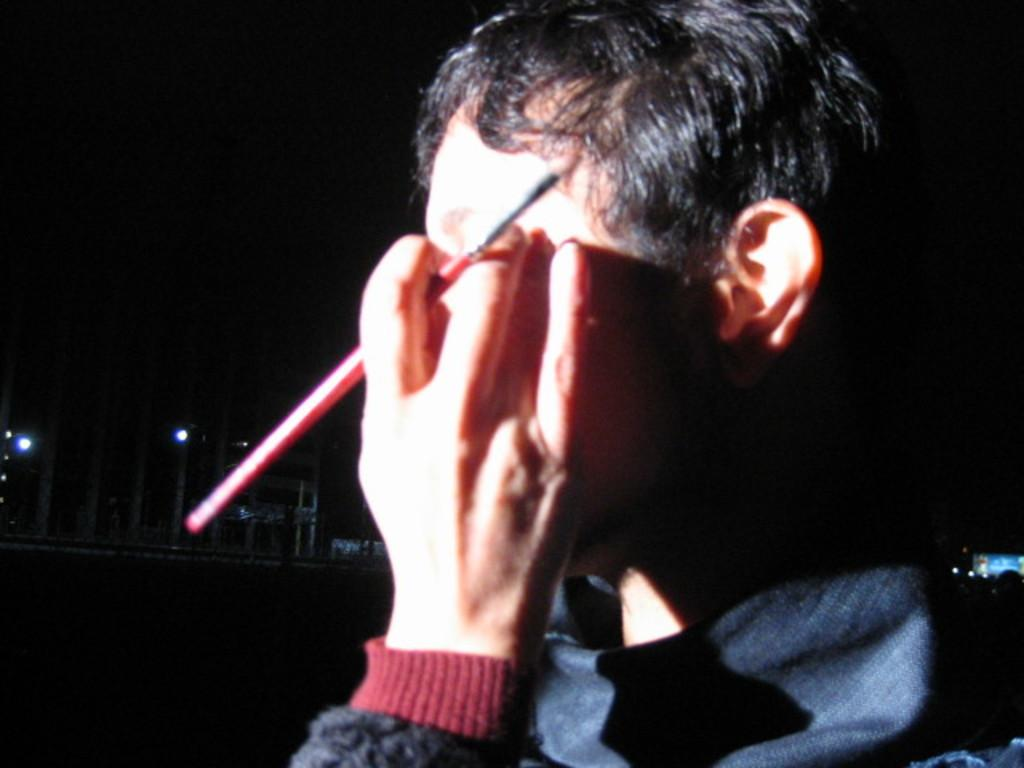Who is present in the image? There is a person in the image. What is the person holding in the image? The person is holding a brush. What can be seen in the background of the image? There are buildings visible behind the person. What else is visible in the image? There are lights visible in the image. What is the writer's reaction to the plot in the image? There is no writer or plot present in the image; it features a person holding a brush and a background with buildings. 